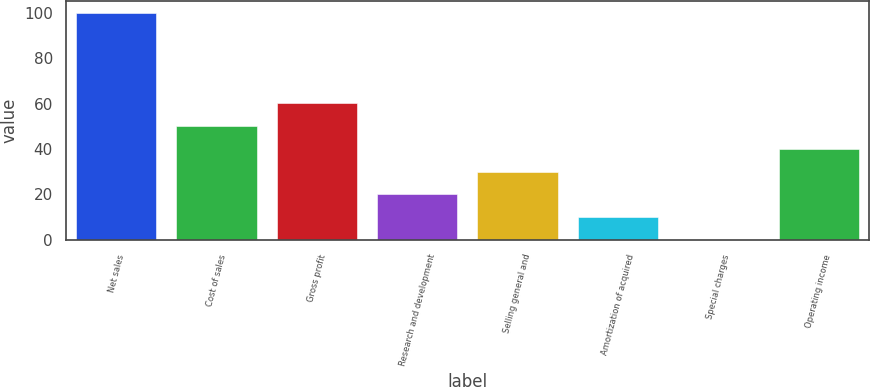Convert chart. <chart><loc_0><loc_0><loc_500><loc_500><bar_chart><fcel>Net sales<fcel>Cost of sales<fcel>Gross profit<fcel>Research and development<fcel>Selling general and<fcel>Amortization of acquired<fcel>Special charges<fcel>Operating income<nl><fcel>100<fcel>50.05<fcel>60.04<fcel>20.08<fcel>30.07<fcel>10.09<fcel>0.1<fcel>40.06<nl></chart> 